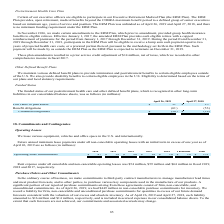From Netapp's financial document, Which years does the table provide information for the funded status of the company's postretirement health care and other defined benefit plans? The document shows two values: 2019 and 2018. From the document: "e sheets, was as follows (in millions): April 26, 2019 April 27, 2018 s follows (in millions): April 26, 2019 April 27, 2018..." Also, What was the fair value of plan assets in 2019? According to the financial document, 31 (in millions). The relevant text states: "Fair value of plan assets $ 31 $ 25..." Also, What were the benefit obligations in 2018? Based on the financial document, the answer is (53) (in millions). Also, can you calculate: What was the change in the fair value of plan assets between 2018 and 2019? Based on the calculation: 31-25, the result is 6 (in millions). This is based on the information: "Fair value of plan assets $ 31 $ 25 Fair value of plan assets $ 31 $ 25..." The key data points involved are: 25, 31. Also, can you calculate: What was the change in benefit obligations between 2018 and 2019? Based on the calculation: -61-(-53), the result is -8 (in millions). This is based on the information: "Benefit obligations (61 ) (53 ) Benefit obligations (61 ) (53 )..." The key data points involved are: 53, 61. Also, can you calculate: What was the percentage change in unfunded obligations between 2018 and 2019? To answer this question, I need to perform calculations using the financial data. The calculation is: (-30-(-28))/-28, which equals 7.14 (percentage). This is based on the information: "Unfunded obligations $ (30 ) $ (28 ) Unfunded obligations $ (30 ) $ (28 )..." The key data points involved are: 28, 30. 